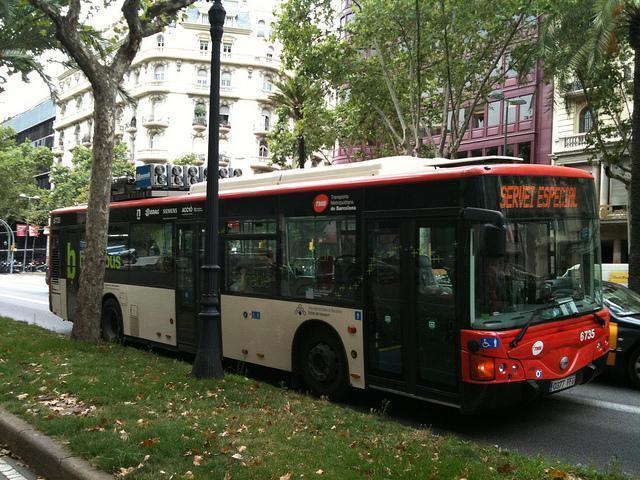How many plates have a sandwich on it?
Give a very brief answer. 0. 